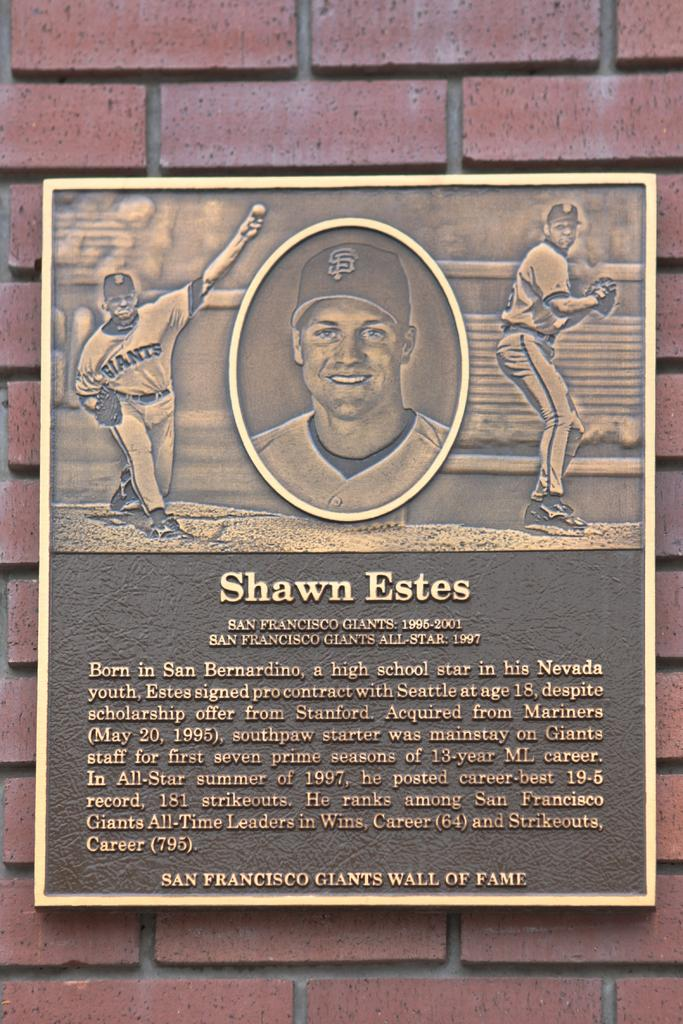<image>
Present a compact description of the photo's key features. A placque for the baseball player Shawn Estes describes him. 